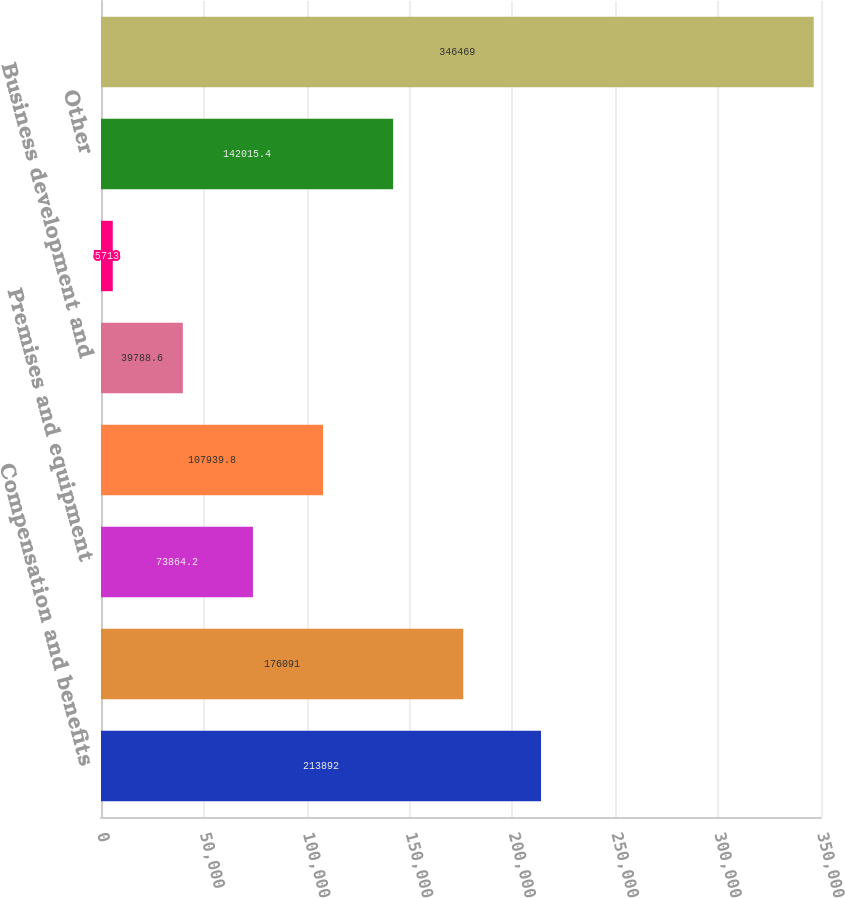<chart> <loc_0><loc_0><loc_500><loc_500><bar_chart><fcel>Compensation and benefits<fcel>Professional services<fcel>Premises and equipment<fcel>Net occupancy<fcel>Business development and<fcel>Correspondent bank fees<fcel>Other<fcel>Total noninterest expense<nl><fcel>213892<fcel>176091<fcel>73864.2<fcel>107940<fcel>39788.6<fcel>5713<fcel>142015<fcel>346469<nl></chart> 